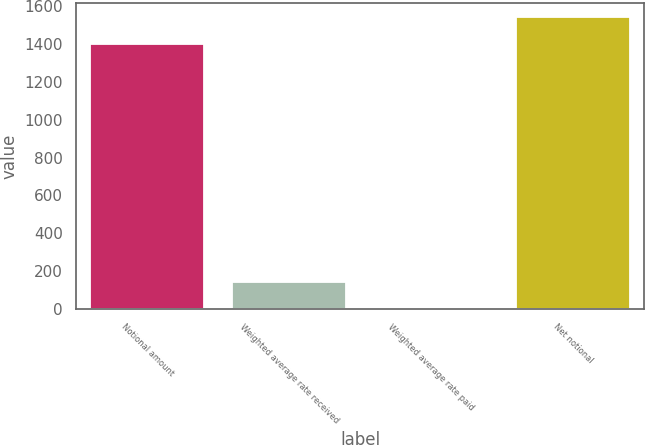Convert chart. <chart><loc_0><loc_0><loc_500><loc_500><bar_chart><fcel>Notional amount<fcel>Weighted average rate received<fcel>Weighted average rate paid<fcel>Net notional<nl><fcel>1400<fcel>144.51<fcel>5.01<fcel>1539.5<nl></chart> 